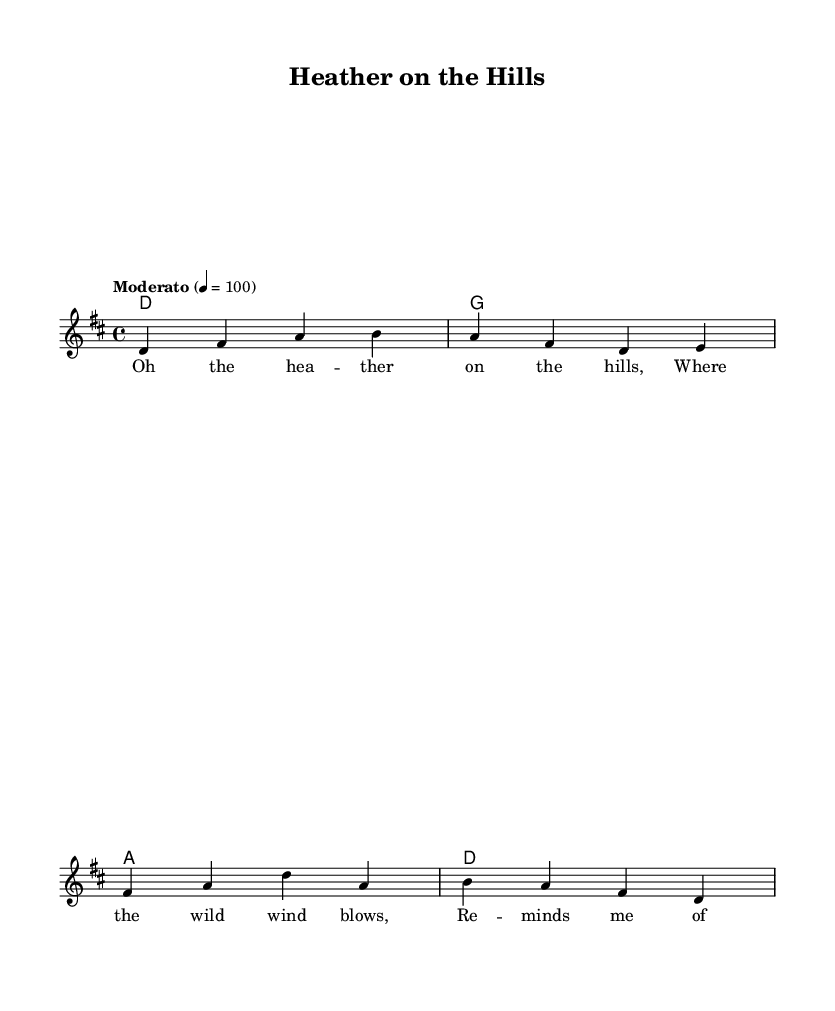What is the key signature of this music? The key signature indicates the presence of two sharps, which corresponds to the D major scale. Therefore, the key signature is D major.
Answer: D major What is the time signature of this music? The time signature is located at the beginning of the sheet music, and it shows that there are four beats in each measure. This is indicated by the 4/4 time signature.
Answer: 4/4 What is the tempo of this piece? The tempo is indicated at the beginning of the score with the word "Moderato," which suggests a moderate pace. Additionally, the metronome marking (4 = 100) implies a speed of 100 beats per minute.
Answer: Moderato How many measures are in the melody? By counting the distinct groups of notes separated by vertical lines, also known as bar lines, we see there are four measures represented in the melody.
Answer: 4 What type of song is "Heather on the Hills"? This piece is identified as a Scottish folk song, which celebrates Highland heritage and reflects themes related to nature and homeland.
Answer: Scottish folk song Which chord is played at the beginning of the piece? The first chord indicated in the harmonies section is 'd', which is a D major chord. This is reinforced by the chord name written above the corresponding measure in the score.
Answer: D major 